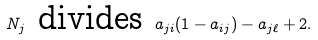Convert formula to latex. <formula><loc_0><loc_0><loc_500><loc_500>N _ { j } \text { divides } a _ { j i } ( 1 - a _ { i j } ) - a _ { j \ell } + 2 .</formula> 